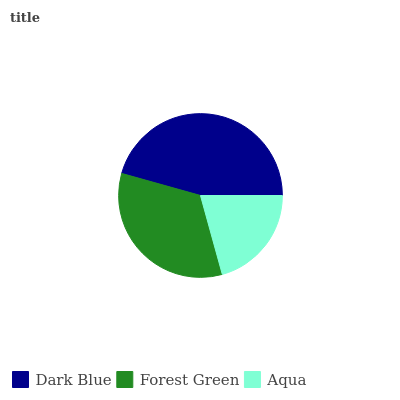Is Aqua the minimum?
Answer yes or no. Yes. Is Dark Blue the maximum?
Answer yes or no. Yes. Is Forest Green the minimum?
Answer yes or no. No. Is Forest Green the maximum?
Answer yes or no. No. Is Dark Blue greater than Forest Green?
Answer yes or no. Yes. Is Forest Green less than Dark Blue?
Answer yes or no. Yes. Is Forest Green greater than Dark Blue?
Answer yes or no. No. Is Dark Blue less than Forest Green?
Answer yes or no. No. Is Forest Green the high median?
Answer yes or no. Yes. Is Forest Green the low median?
Answer yes or no. Yes. Is Aqua the high median?
Answer yes or no. No. Is Dark Blue the low median?
Answer yes or no. No. 